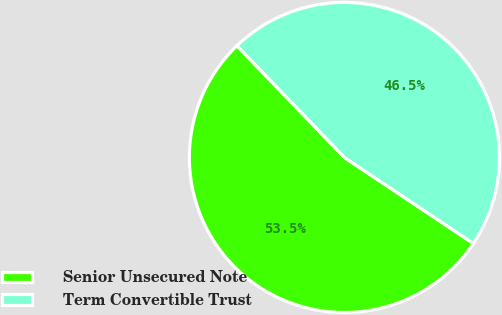<chart> <loc_0><loc_0><loc_500><loc_500><pie_chart><fcel>Senior Unsecured Note<fcel>Term Convertible Trust<nl><fcel>53.45%<fcel>46.55%<nl></chart> 